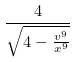<formula> <loc_0><loc_0><loc_500><loc_500>\frac { 4 } { \sqrt { 4 - \frac { v ^ { 9 } } { x ^ { 9 } } } }</formula> 